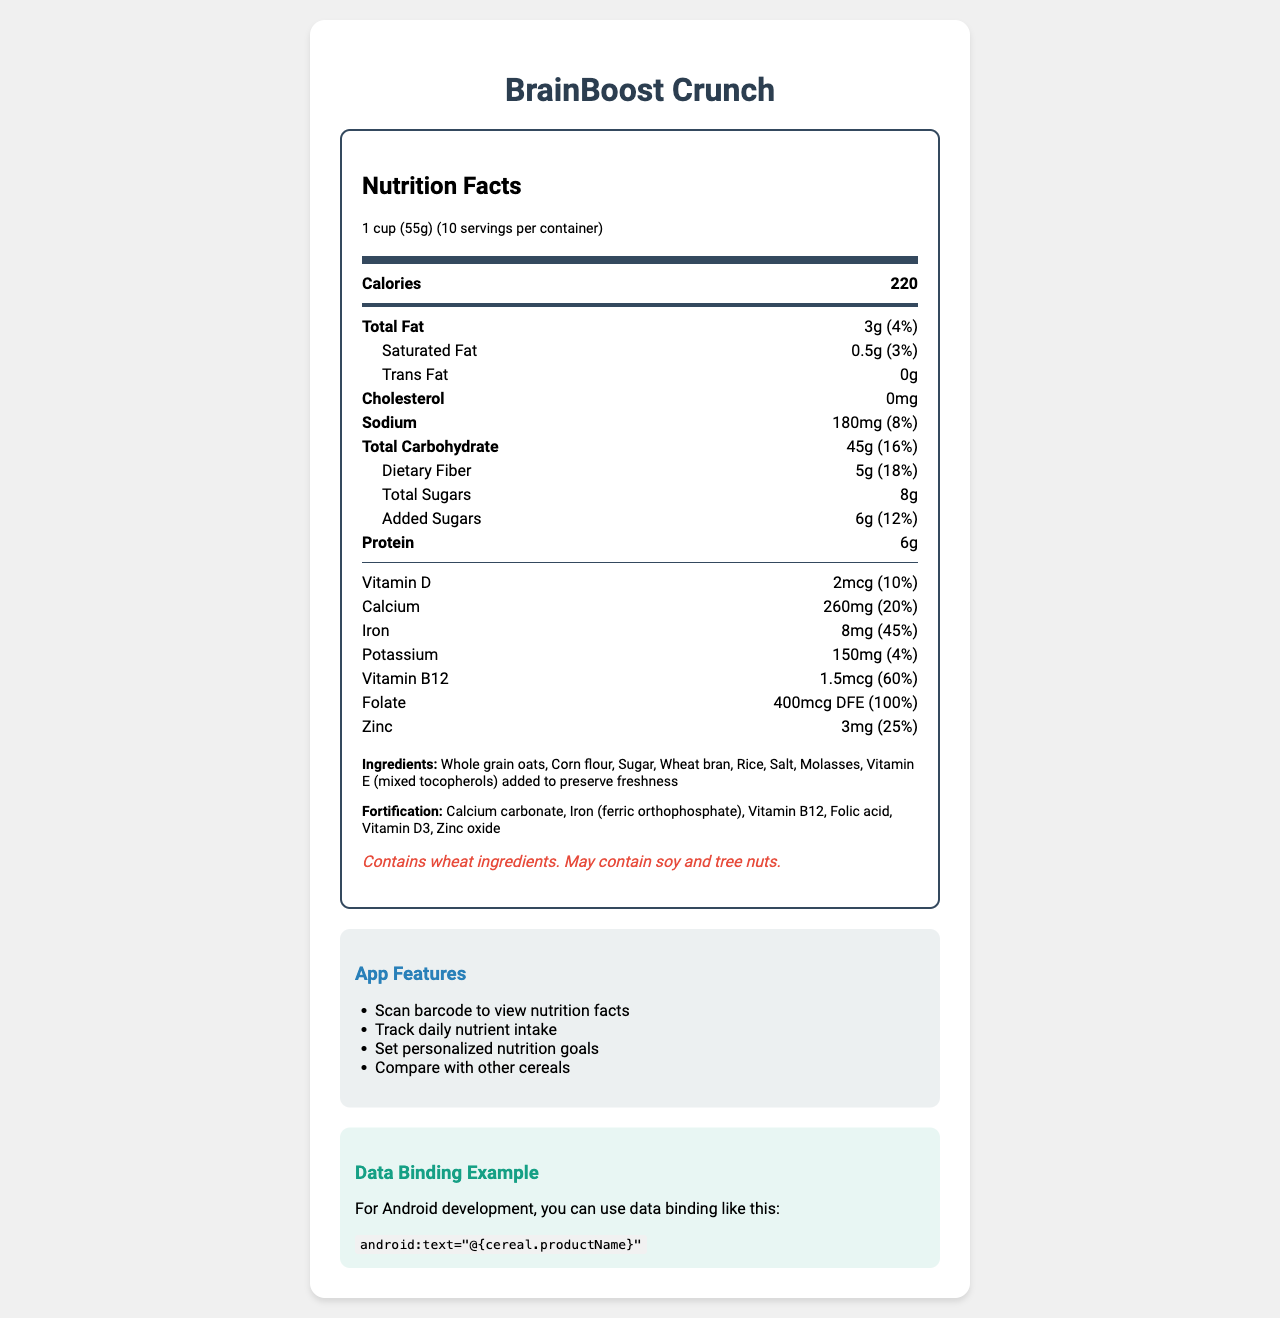what is the serving size of BrainBoost Crunch? The serving size is clearly mentioned as "1 cup (55g)" in the nutrition facts.
Answer: 1 cup (55g) how many servings are in the container? The document states that there are 10 servings per container.
Answer: 10 how many calories are there per serving? The document lists the calories per serving as 220.
Answer: 220 how much total fat is in each serving? The total fat content per serving is listed as 3g.
Answer: 3g what percentage of Daily Value does the iron content represent? The iron content per serving represents 45% of the Daily Value.
Answer: 45% Which nutrient has the highest daily value percentage per serving? A. Vitamin B12 B. Folate C. Iron D. Calcium Folate has the highest daily value percentage at 100%, compared to Vitamin B12 (60%), Iron (45%), and Calcium (20%).
Answer: B. Folate How much added sugar is there per serving? A. 5g B. 6g C. 7g D. 8g The added sugar per serving is listed as 6g.
Answer: B. 6g Does the product contain any cholesterol? The document shows cholesterol content as "0mg," indicating that there is no cholesterol in the product.
Answer: No Does the product contain any allergens? The allergen information notes that the product contains wheat ingredients and may contain soy and tree nuts.
Answer: Yes How is the android data binding example implemented in the document? The specifics of how the android data binding example is implemented are not detailed in the visual information of the document.
Answer: Cannot be determined summarize the features emphasized in the document. The document provides a detailed breakdown of the nutritional content of BrainBoost Crunch, emphasizing its health benefits, fortification, and allergen information. It also highlights useful app features for tracking and comparing dietary intake.
Answer: BrainBoost Crunch is a fortified breakfast cereal with 220 calories per serving. It provides significant daily values of Folate, Iron, and Vitamin B12. It also has additional beneficial nutrients and low amounts of saturated fat and cholesterol. The document outlines ingredients, fortification elements, allergen information, and outlines app features focused on tracking and comparing nutrition facts. 